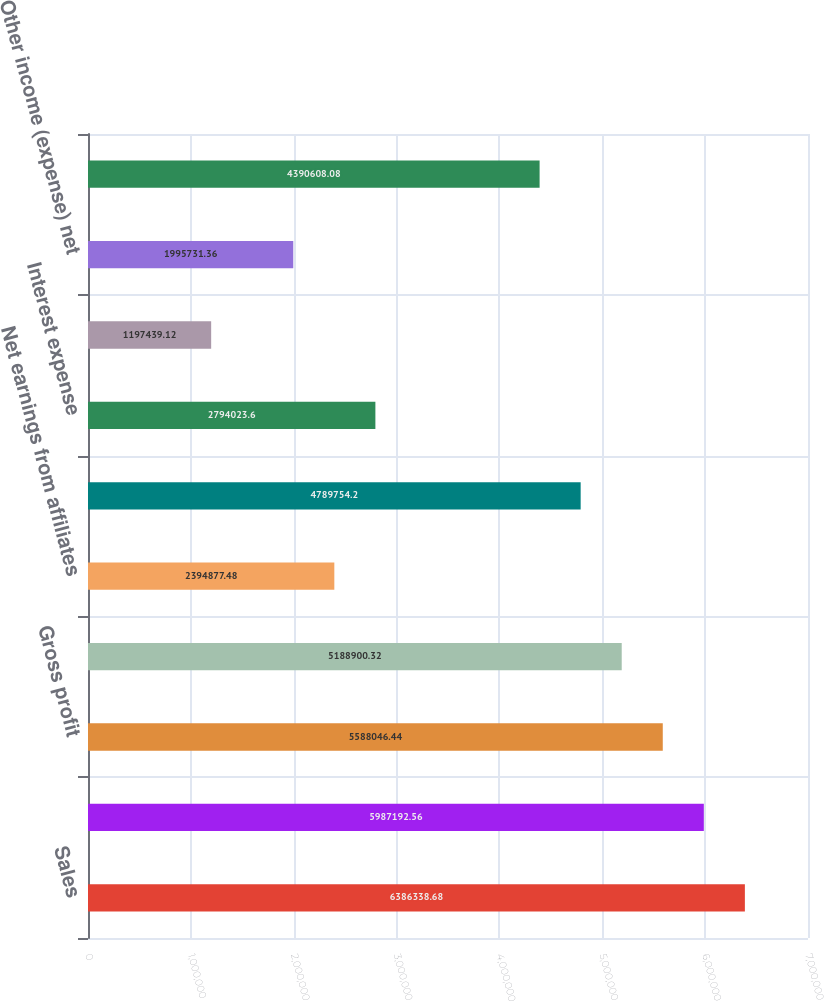Convert chart. <chart><loc_0><loc_0><loc_500><loc_500><bar_chart><fcel>Sales<fcel>Cost of sales<fcel>Gross profit<fcel>Selling general and<fcel>Net earnings from affiliates<fcel>Operating income<fcel>Interest expense<fcel>Interest income<fcel>Other income (expense) net<fcel>Earnings before income taxes<nl><fcel>6.38634e+06<fcel>5.98719e+06<fcel>5.58805e+06<fcel>5.1889e+06<fcel>2.39488e+06<fcel>4.78975e+06<fcel>2.79402e+06<fcel>1.19744e+06<fcel>1.99573e+06<fcel>4.39061e+06<nl></chart> 